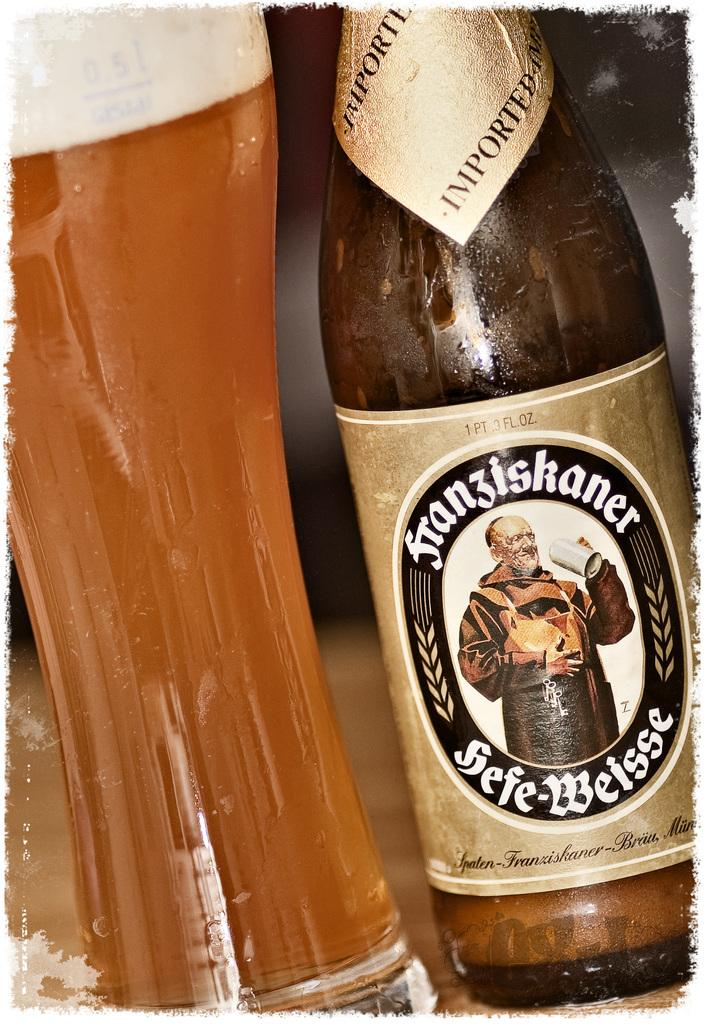<image>
Render a clear and concise summary of the photo. A bottle with a gold and black labell says imported around the neck of the bottle. 